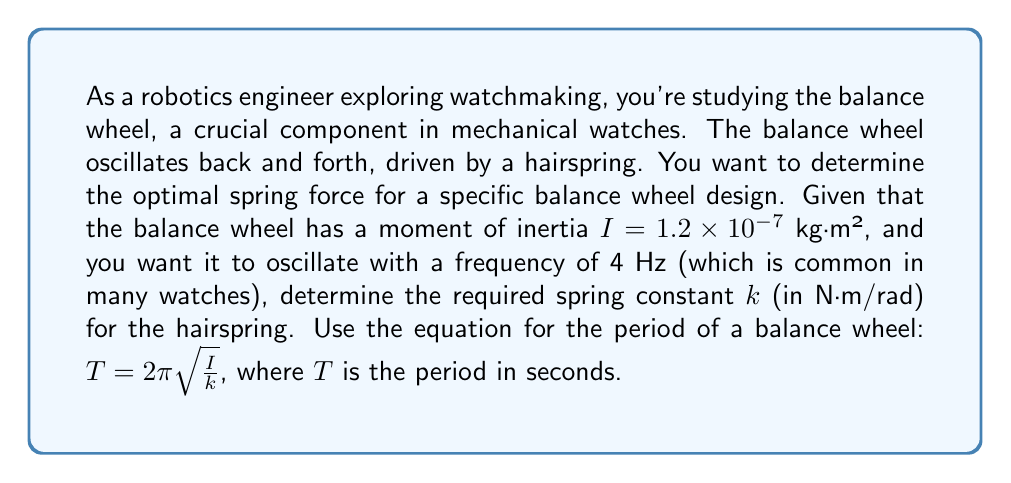Solve this math problem. Let's approach this step-by-step:

1) First, we need to convert the frequency to period. The relationship between frequency ($f$) and period ($T$) is:

   $T = \frac{1}{f}$

   Given $f = 4$ Hz, we have:
   $T = \frac{1}{4} = 0.25$ seconds

2) Now we can use the equation for the period of a balance wheel:

   $T = 2\pi \sqrt{\frac{I}{k}}$

3) We know $T = 0.25$ s and $I = 1.2 \times 10^{-7}$ kg·m². Let's substitute these values:

   $0.25 = 2\pi \sqrt{\frac{1.2 \times 10^{-7}}{k}}$

4) To solve for $k$, let's first square both sides:

   $(0.25)^2 = (2\pi)^2 \frac{1.2 \times 10^{-7}}{k}$

5) Simplify:

   $0.0625 = 4\pi^2 \frac{1.2 \times 10^{-7}}{k}$

6) Multiply both sides by $k$:

   $0.0625k = 4\pi^2 (1.2 \times 10^{-7})$

7) Divide both sides by 0.0625:

   $k = \frac{4\pi^2 (1.2 \times 10^{-7})}{0.0625}$

8) Calculate:

   $k \approx 1.18 \times 10^{-4}$ N·m/rad

This is the required spring constant for the hairspring to make the balance wheel oscillate at 4 Hz.
Answer: The optimal spring constant $k$ for the hairspring is approximately $1.18 \times 10^{-4}$ N·m/rad. 